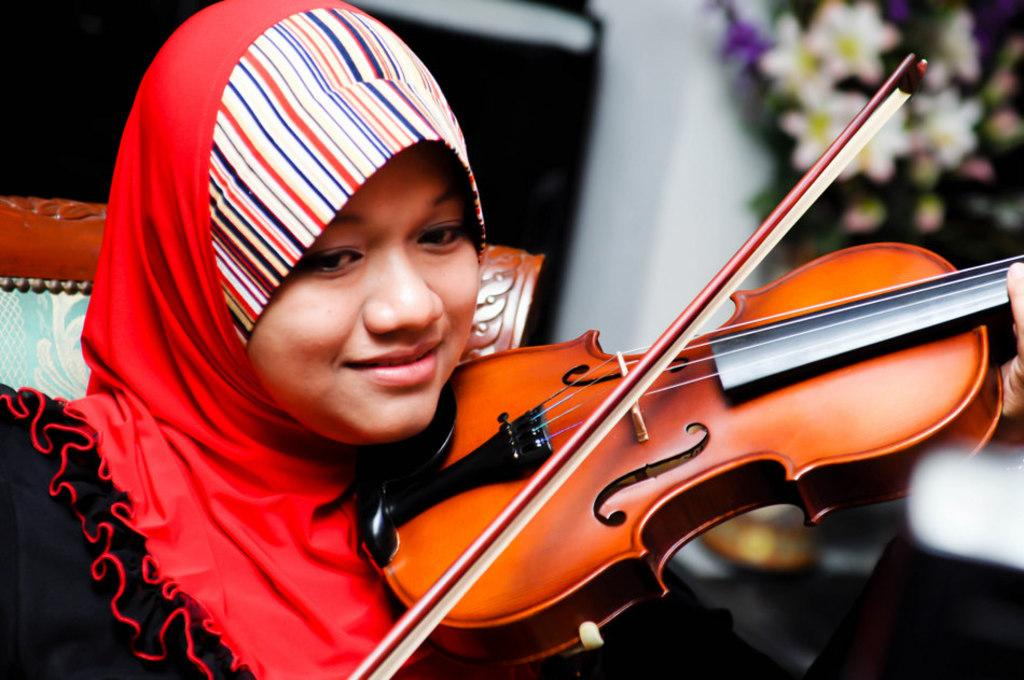What is the person in the image doing? The person is sitting on a chair. What object is the person holding in the image? The person is holding a violin. What type of mask is the person wearing in the image? There is no mask present in the image; the person is only holding a violin. 